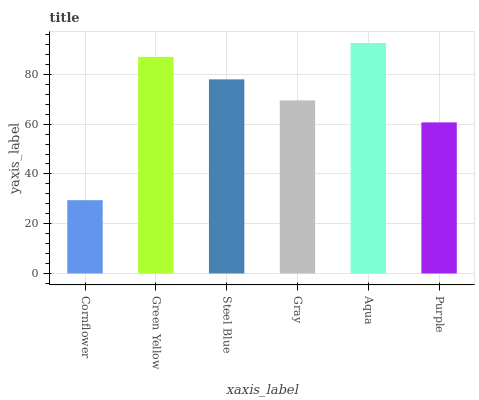Is Cornflower the minimum?
Answer yes or no. Yes. Is Aqua the maximum?
Answer yes or no. Yes. Is Green Yellow the minimum?
Answer yes or no. No. Is Green Yellow the maximum?
Answer yes or no. No. Is Green Yellow greater than Cornflower?
Answer yes or no. Yes. Is Cornflower less than Green Yellow?
Answer yes or no. Yes. Is Cornflower greater than Green Yellow?
Answer yes or no. No. Is Green Yellow less than Cornflower?
Answer yes or no. No. Is Steel Blue the high median?
Answer yes or no. Yes. Is Gray the low median?
Answer yes or no. Yes. Is Aqua the high median?
Answer yes or no. No. Is Steel Blue the low median?
Answer yes or no. No. 